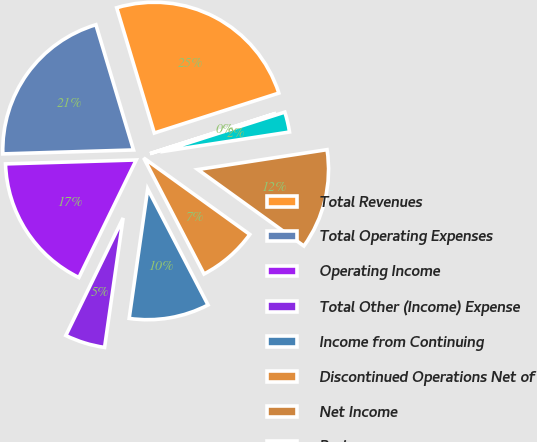Convert chart. <chart><loc_0><loc_0><loc_500><loc_500><pie_chart><fcel>Total Revenues<fcel>Total Operating Expenses<fcel>Operating Income<fcel>Total Other (Income) Expense<fcel>Income from Continuing<fcel>Discontinued Operations Net of<fcel>Net Income<fcel>Basic<fcel>Diluted<nl><fcel>24.71%<fcel>20.84%<fcel>17.3%<fcel>4.96%<fcel>9.9%<fcel>7.43%<fcel>12.37%<fcel>2.49%<fcel>0.02%<nl></chart> 